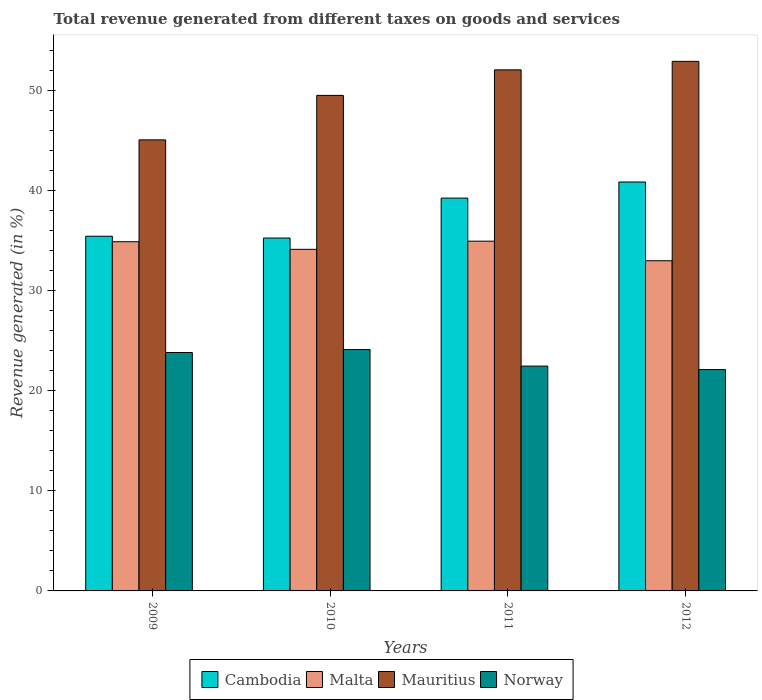Are the number of bars per tick equal to the number of legend labels?
Provide a succinct answer. Yes. Are the number of bars on each tick of the X-axis equal?
Provide a succinct answer. Yes. How many bars are there on the 2nd tick from the left?
Offer a terse response. 4. What is the label of the 3rd group of bars from the left?
Provide a succinct answer. 2011. What is the total revenue generated in Norway in 2012?
Offer a terse response. 22.14. Across all years, what is the maximum total revenue generated in Malta?
Provide a short and direct response. 34.98. Across all years, what is the minimum total revenue generated in Mauritius?
Give a very brief answer. 45.11. What is the total total revenue generated in Malta in the graph?
Make the answer very short. 137.08. What is the difference between the total revenue generated in Malta in 2009 and that in 2011?
Provide a succinct answer. -0.05. What is the difference between the total revenue generated in Malta in 2011 and the total revenue generated in Cambodia in 2010?
Offer a very short reply. -0.31. What is the average total revenue generated in Mauritius per year?
Keep it short and to the point. 49.93. In the year 2011, what is the difference between the total revenue generated in Cambodia and total revenue generated in Mauritius?
Provide a short and direct response. -12.83. In how many years, is the total revenue generated in Malta greater than 36 %?
Give a very brief answer. 0. What is the ratio of the total revenue generated in Cambodia in 2011 to that in 2012?
Your answer should be very brief. 0.96. What is the difference between the highest and the second highest total revenue generated in Malta?
Provide a short and direct response. 0.05. What is the difference between the highest and the lowest total revenue generated in Mauritius?
Give a very brief answer. 7.85. Is it the case that in every year, the sum of the total revenue generated in Malta and total revenue generated in Norway is greater than the sum of total revenue generated in Mauritius and total revenue generated in Cambodia?
Offer a terse response. No. What does the 3rd bar from the left in 2009 represents?
Your response must be concise. Mauritius. How many bars are there?
Provide a short and direct response. 16. Are the values on the major ticks of Y-axis written in scientific E-notation?
Provide a succinct answer. No. Does the graph contain any zero values?
Offer a very short reply. No. Where does the legend appear in the graph?
Provide a succinct answer. Bottom center. What is the title of the graph?
Your answer should be compact. Total revenue generated from different taxes on goods and services. What is the label or title of the X-axis?
Your response must be concise. Years. What is the label or title of the Y-axis?
Make the answer very short. Revenue generated (in %). What is the Revenue generated (in %) of Cambodia in 2009?
Offer a terse response. 35.47. What is the Revenue generated (in %) of Malta in 2009?
Give a very brief answer. 34.92. What is the Revenue generated (in %) in Mauritius in 2009?
Keep it short and to the point. 45.11. What is the Revenue generated (in %) in Norway in 2009?
Keep it short and to the point. 23.84. What is the Revenue generated (in %) in Cambodia in 2010?
Ensure brevity in your answer.  35.29. What is the Revenue generated (in %) in Malta in 2010?
Offer a very short reply. 34.16. What is the Revenue generated (in %) in Mauritius in 2010?
Provide a short and direct response. 49.56. What is the Revenue generated (in %) in Norway in 2010?
Your answer should be compact. 24.14. What is the Revenue generated (in %) of Cambodia in 2011?
Your response must be concise. 39.28. What is the Revenue generated (in %) in Malta in 2011?
Your answer should be very brief. 34.98. What is the Revenue generated (in %) of Mauritius in 2011?
Your response must be concise. 52.11. What is the Revenue generated (in %) of Norway in 2011?
Offer a terse response. 22.48. What is the Revenue generated (in %) of Cambodia in 2012?
Make the answer very short. 40.9. What is the Revenue generated (in %) of Malta in 2012?
Make the answer very short. 33.02. What is the Revenue generated (in %) in Mauritius in 2012?
Offer a very short reply. 52.96. What is the Revenue generated (in %) of Norway in 2012?
Give a very brief answer. 22.14. Across all years, what is the maximum Revenue generated (in %) of Cambodia?
Offer a terse response. 40.9. Across all years, what is the maximum Revenue generated (in %) of Malta?
Your answer should be very brief. 34.98. Across all years, what is the maximum Revenue generated (in %) in Mauritius?
Make the answer very short. 52.96. Across all years, what is the maximum Revenue generated (in %) of Norway?
Your answer should be compact. 24.14. Across all years, what is the minimum Revenue generated (in %) of Cambodia?
Offer a terse response. 35.29. Across all years, what is the minimum Revenue generated (in %) in Malta?
Make the answer very short. 33.02. Across all years, what is the minimum Revenue generated (in %) of Mauritius?
Provide a short and direct response. 45.11. Across all years, what is the minimum Revenue generated (in %) in Norway?
Offer a very short reply. 22.14. What is the total Revenue generated (in %) of Cambodia in the graph?
Your answer should be very brief. 150.94. What is the total Revenue generated (in %) in Malta in the graph?
Provide a short and direct response. 137.08. What is the total Revenue generated (in %) of Mauritius in the graph?
Your response must be concise. 199.73. What is the total Revenue generated (in %) of Norway in the graph?
Offer a very short reply. 92.61. What is the difference between the Revenue generated (in %) in Cambodia in 2009 and that in 2010?
Provide a succinct answer. 0.18. What is the difference between the Revenue generated (in %) of Malta in 2009 and that in 2010?
Ensure brevity in your answer.  0.76. What is the difference between the Revenue generated (in %) of Mauritius in 2009 and that in 2010?
Your answer should be compact. -4.45. What is the difference between the Revenue generated (in %) of Cambodia in 2009 and that in 2011?
Give a very brief answer. -3.81. What is the difference between the Revenue generated (in %) in Malta in 2009 and that in 2011?
Your answer should be very brief. -0.05. What is the difference between the Revenue generated (in %) of Mauritius in 2009 and that in 2011?
Offer a terse response. -7. What is the difference between the Revenue generated (in %) of Norway in 2009 and that in 2011?
Provide a short and direct response. 1.36. What is the difference between the Revenue generated (in %) of Cambodia in 2009 and that in 2012?
Offer a very short reply. -5.42. What is the difference between the Revenue generated (in %) of Malta in 2009 and that in 2012?
Offer a very short reply. 1.9. What is the difference between the Revenue generated (in %) of Mauritius in 2009 and that in 2012?
Give a very brief answer. -7.85. What is the difference between the Revenue generated (in %) of Norway in 2009 and that in 2012?
Your answer should be very brief. 1.71. What is the difference between the Revenue generated (in %) in Cambodia in 2010 and that in 2011?
Offer a terse response. -3.99. What is the difference between the Revenue generated (in %) of Malta in 2010 and that in 2011?
Your response must be concise. -0.82. What is the difference between the Revenue generated (in %) of Mauritius in 2010 and that in 2011?
Your answer should be compact. -2.56. What is the difference between the Revenue generated (in %) in Norway in 2010 and that in 2011?
Ensure brevity in your answer.  1.66. What is the difference between the Revenue generated (in %) in Cambodia in 2010 and that in 2012?
Provide a succinct answer. -5.6. What is the difference between the Revenue generated (in %) of Malta in 2010 and that in 2012?
Keep it short and to the point. 1.14. What is the difference between the Revenue generated (in %) of Mauritius in 2010 and that in 2012?
Make the answer very short. -3.41. What is the difference between the Revenue generated (in %) of Norway in 2010 and that in 2012?
Make the answer very short. 2.01. What is the difference between the Revenue generated (in %) in Cambodia in 2011 and that in 2012?
Provide a short and direct response. -1.61. What is the difference between the Revenue generated (in %) of Malta in 2011 and that in 2012?
Your answer should be compact. 1.96. What is the difference between the Revenue generated (in %) of Mauritius in 2011 and that in 2012?
Keep it short and to the point. -0.85. What is the difference between the Revenue generated (in %) of Norway in 2011 and that in 2012?
Provide a short and direct response. 0.35. What is the difference between the Revenue generated (in %) of Cambodia in 2009 and the Revenue generated (in %) of Malta in 2010?
Provide a succinct answer. 1.31. What is the difference between the Revenue generated (in %) in Cambodia in 2009 and the Revenue generated (in %) in Mauritius in 2010?
Ensure brevity in your answer.  -14.08. What is the difference between the Revenue generated (in %) of Cambodia in 2009 and the Revenue generated (in %) of Norway in 2010?
Make the answer very short. 11.33. What is the difference between the Revenue generated (in %) of Malta in 2009 and the Revenue generated (in %) of Mauritius in 2010?
Your response must be concise. -14.63. What is the difference between the Revenue generated (in %) of Malta in 2009 and the Revenue generated (in %) of Norway in 2010?
Make the answer very short. 10.78. What is the difference between the Revenue generated (in %) of Mauritius in 2009 and the Revenue generated (in %) of Norway in 2010?
Your response must be concise. 20.97. What is the difference between the Revenue generated (in %) of Cambodia in 2009 and the Revenue generated (in %) of Malta in 2011?
Your answer should be very brief. 0.49. What is the difference between the Revenue generated (in %) of Cambodia in 2009 and the Revenue generated (in %) of Mauritius in 2011?
Your response must be concise. -16.64. What is the difference between the Revenue generated (in %) in Cambodia in 2009 and the Revenue generated (in %) in Norway in 2011?
Keep it short and to the point. 12.99. What is the difference between the Revenue generated (in %) in Malta in 2009 and the Revenue generated (in %) in Mauritius in 2011?
Offer a terse response. -17.19. What is the difference between the Revenue generated (in %) in Malta in 2009 and the Revenue generated (in %) in Norway in 2011?
Provide a short and direct response. 12.44. What is the difference between the Revenue generated (in %) in Mauritius in 2009 and the Revenue generated (in %) in Norway in 2011?
Make the answer very short. 22.62. What is the difference between the Revenue generated (in %) of Cambodia in 2009 and the Revenue generated (in %) of Malta in 2012?
Your response must be concise. 2.45. What is the difference between the Revenue generated (in %) of Cambodia in 2009 and the Revenue generated (in %) of Mauritius in 2012?
Your answer should be very brief. -17.49. What is the difference between the Revenue generated (in %) of Cambodia in 2009 and the Revenue generated (in %) of Norway in 2012?
Offer a very short reply. 13.33. What is the difference between the Revenue generated (in %) in Malta in 2009 and the Revenue generated (in %) in Mauritius in 2012?
Your answer should be very brief. -18.04. What is the difference between the Revenue generated (in %) in Malta in 2009 and the Revenue generated (in %) in Norway in 2012?
Provide a short and direct response. 12.79. What is the difference between the Revenue generated (in %) of Mauritius in 2009 and the Revenue generated (in %) of Norway in 2012?
Your answer should be compact. 22.97. What is the difference between the Revenue generated (in %) in Cambodia in 2010 and the Revenue generated (in %) in Malta in 2011?
Offer a terse response. 0.31. What is the difference between the Revenue generated (in %) in Cambodia in 2010 and the Revenue generated (in %) in Mauritius in 2011?
Your response must be concise. -16.82. What is the difference between the Revenue generated (in %) in Cambodia in 2010 and the Revenue generated (in %) in Norway in 2011?
Make the answer very short. 12.81. What is the difference between the Revenue generated (in %) of Malta in 2010 and the Revenue generated (in %) of Mauritius in 2011?
Your answer should be very brief. -17.95. What is the difference between the Revenue generated (in %) in Malta in 2010 and the Revenue generated (in %) in Norway in 2011?
Make the answer very short. 11.68. What is the difference between the Revenue generated (in %) of Mauritius in 2010 and the Revenue generated (in %) of Norway in 2011?
Offer a terse response. 27.07. What is the difference between the Revenue generated (in %) in Cambodia in 2010 and the Revenue generated (in %) in Malta in 2012?
Provide a succinct answer. 2.27. What is the difference between the Revenue generated (in %) of Cambodia in 2010 and the Revenue generated (in %) of Mauritius in 2012?
Make the answer very short. -17.67. What is the difference between the Revenue generated (in %) in Cambodia in 2010 and the Revenue generated (in %) in Norway in 2012?
Your response must be concise. 13.15. What is the difference between the Revenue generated (in %) in Malta in 2010 and the Revenue generated (in %) in Mauritius in 2012?
Offer a very short reply. -18.8. What is the difference between the Revenue generated (in %) in Malta in 2010 and the Revenue generated (in %) in Norway in 2012?
Offer a very short reply. 12.03. What is the difference between the Revenue generated (in %) in Mauritius in 2010 and the Revenue generated (in %) in Norway in 2012?
Offer a terse response. 27.42. What is the difference between the Revenue generated (in %) in Cambodia in 2011 and the Revenue generated (in %) in Malta in 2012?
Make the answer very short. 6.26. What is the difference between the Revenue generated (in %) in Cambodia in 2011 and the Revenue generated (in %) in Mauritius in 2012?
Ensure brevity in your answer.  -13.68. What is the difference between the Revenue generated (in %) of Cambodia in 2011 and the Revenue generated (in %) of Norway in 2012?
Your answer should be compact. 17.15. What is the difference between the Revenue generated (in %) in Malta in 2011 and the Revenue generated (in %) in Mauritius in 2012?
Give a very brief answer. -17.98. What is the difference between the Revenue generated (in %) of Malta in 2011 and the Revenue generated (in %) of Norway in 2012?
Ensure brevity in your answer.  12.84. What is the difference between the Revenue generated (in %) in Mauritius in 2011 and the Revenue generated (in %) in Norway in 2012?
Your answer should be compact. 29.97. What is the average Revenue generated (in %) of Cambodia per year?
Your answer should be compact. 37.74. What is the average Revenue generated (in %) in Malta per year?
Your response must be concise. 34.27. What is the average Revenue generated (in %) in Mauritius per year?
Ensure brevity in your answer.  49.93. What is the average Revenue generated (in %) in Norway per year?
Your answer should be compact. 23.15. In the year 2009, what is the difference between the Revenue generated (in %) of Cambodia and Revenue generated (in %) of Malta?
Keep it short and to the point. 0.55. In the year 2009, what is the difference between the Revenue generated (in %) in Cambodia and Revenue generated (in %) in Mauritius?
Provide a succinct answer. -9.64. In the year 2009, what is the difference between the Revenue generated (in %) in Cambodia and Revenue generated (in %) in Norway?
Your response must be concise. 11.63. In the year 2009, what is the difference between the Revenue generated (in %) of Malta and Revenue generated (in %) of Mauritius?
Your answer should be very brief. -10.19. In the year 2009, what is the difference between the Revenue generated (in %) of Malta and Revenue generated (in %) of Norway?
Keep it short and to the point. 11.08. In the year 2009, what is the difference between the Revenue generated (in %) in Mauritius and Revenue generated (in %) in Norway?
Give a very brief answer. 21.27. In the year 2010, what is the difference between the Revenue generated (in %) of Cambodia and Revenue generated (in %) of Malta?
Your answer should be compact. 1.13. In the year 2010, what is the difference between the Revenue generated (in %) in Cambodia and Revenue generated (in %) in Mauritius?
Provide a short and direct response. -14.26. In the year 2010, what is the difference between the Revenue generated (in %) in Cambodia and Revenue generated (in %) in Norway?
Keep it short and to the point. 11.15. In the year 2010, what is the difference between the Revenue generated (in %) of Malta and Revenue generated (in %) of Mauritius?
Keep it short and to the point. -15.39. In the year 2010, what is the difference between the Revenue generated (in %) of Malta and Revenue generated (in %) of Norway?
Your answer should be compact. 10.02. In the year 2010, what is the difference between the Revenue generated (in %) of Mauritius and Revenue generated (in %) of Norway?
Provide a short and direct response. 25.41. In the year 2011, what is the difference between the Revenue generated (in %) of Cambodia and Revenue generated (in %) of Malta?
Keep it short and to the point. 4.31. In the year 2011, what is the difference between the Revenue generated (in %) in Cambodia and Revenue generated (in %) in Mauritius?
Give a very brief answer. -12.83. In the year 2011, what is the difference between the Revenue generated (in %) of Cambodia and Revenue generated (in %) of Norway?
Provide a short and direct response. 16.8. In the year 2011, what is the difference between the Revenue generated (in %) of Malta and Revenue generated (in %) of Mauritius?
Your response must be concise. -17.13. In the year 2011, what is the difference between the Revenue generated (in %) of Malta and Revenue generated (in %) of Norway?
Your answer should be very brief. 12.49. In the year 2011, what is the difference between the Revenue generated (in %) of Mauritius and Revenue generated (in %) of Norway?
Keep it short and to the point. 29.63. In the year 2012, what is the difference between the Revenue generated (in %) in Cambodia and Revenue generated (in %) in Malta?
Your response must be concise. 7.87. In the year 2012, what is the difference between the Revenue generated (in %) of Cambodia and Revenue generated (in %) of Mauritius?
Your answer should be compact. -12.07. In the year 2012, what is the difference between the Revenue generated (in %) in Cambodia and Revenue generated (in %) in Norway?
Provide a succinct answer. 18.76. In the year 2012, what is the difference between the Revenue generated (in %) of Malta and Revenue generated (in %) of Mauritius?
Keep it short and to the point. -19.94. In the year 2012, what is the difference between the Revenue generated (in %) in Malta and Revenue generated (in %) in Norway?
Make the answer very short. 10.88. In the year 2012, what is the difference between the Revenue generated (in %) in Mauritius and Revenue generated (in %) in Norway?
Your response must be concise. 30.82. What is the ratio of the Revenue generated (in %) in Cambodia in 2009 to that in 2010?
Offer a terse response. 1.01. What is the ratio of the Revenue generated (in %) in Malta in 2009 to that in 2010?
Your answer should be compact. 1.02. What is the ratio of the Revenue generated (in %) of Mauritius in 2009 to that in 2010?
Ensure brevity in your answer.  0.91. What is the ratio of the Revenue generated (in %) in Norway in 2009 to that in 2010?
Your answer should be compact. 0.99. What is the ratio of the Revenue generated (in %) in Cambodia in 2009 to that in 2011?
Ensure brevity in your answer.  0.9. What is the ratio of the Revenue generated (in %) in Malta in 2009 to that in 2011?
Your answer should be very brief. 1. What is the ratio of the Revenue generated (in %) in Mauritius in 2009 to that in 2011?
Offer a terse response. 0.87. What is the ratio of the Revenue generated (in %) in Norway in 2009 to that in 2011?
Offer a very short reply. 1.06. What is the ratio of the Revenue generated (in %) in Cambodia in 2009 to that in 2012?
Provide a short and direct response. 0.87. What is the ratio of the Revenue generated (in %) of Malta in 2009 to that in 2012?
Your answer should be very brief. 1.06. What is the ratio of the Revenue generated (in %) of Mauritius in 2009 to that in 2012?
Ensure brevity in your answer.  0.85. What is the ratio of the Revenue generated (in %) in Norway in 2009 to that in 2012?
Provide a short and direct response. 1.08. What is the ratio of the Revenue generated (in %) of Cambodia in 2010 to that in 2011?
Give a very brief answer. 0.9. What is the ratio of the Revenue generated (in %) of Malta in 2010 to that in 2011?
Make the answer very short. 0.98. What is the ratio of the Revenue generated (in %) of Mauritius in 2010 to that in 2011?
Offer a terse response. 0.95. What is the ratio of the Revenue generated (in %) in Norway in 2010 to that in 2011?
Make the answer very short. 1.07. What is the ratio of the Revenue generated (in %) of Cambodia in 2010 to that in 2012?
Keep it short and to the point. 0.86. What is the ratio of the Revenue generated (in %) in Malta in 2010 to that in 2012?
Offer a terse response. 1.03. What is the ratio of the Revenue generated (in %) of Mauritius in 2010 to that in 2012?
Your answer should be compact. 0.94. What is the ratio of the Revenue generated (in %) of Norway in 2010 to that in 2012?
Offer a terse response. 1.09. What is the ratio of the Revenue generated (in %) of Cambodia in 2011 to that in 2012?
Give a very brief answer. 0.96. What is the ratio of the Revenue generated (in %) in Malta in 2011 to that in 2012?
Ensure brevity in your answer.  1.06. What is the ratio of the Revenue generated (in %) of Mauritius in 2011 to that in 2012?
Offer a terse response. 0.98. What is the ratio of the Revenue generated (in %) of Norway in 2011 to that in 2012?
Provide a succinct answer. 1.02. What is the difference between the highest and the second highest Revenue generated (in %) of Cambodia?
Give a very brief answer. 1.61. What is the difference between the highest and the second highest Revenue generated (in %) in Malta?
Your answer should be very brief. 0.05. What is the difference between the highest and the second highest Revenue generated (in %) in Mauritius?
Ensure brevity in your answer.  0.85. What is the difference between the highest and the second highest Revenue generated (in %) in Norway?
Ensure brevity in your answer.  0.3. What is the difference between the highest and the lowest Revenue generated (in %) of Cambodia?
Give a very brief answer. 5.6. What is the difference between the highest and the lowest Revenue generated (in %) in Malta?
Provide a succinct answer. 1.96. What is the difference between the highest and the lowest Revenue generated (in %) in Mauritius?
Provide a short and direct response. 7.85. What is the difference between the highest and the lowest Revenue generated (in %) of Norway?
Offer a terse response. 2.01. 